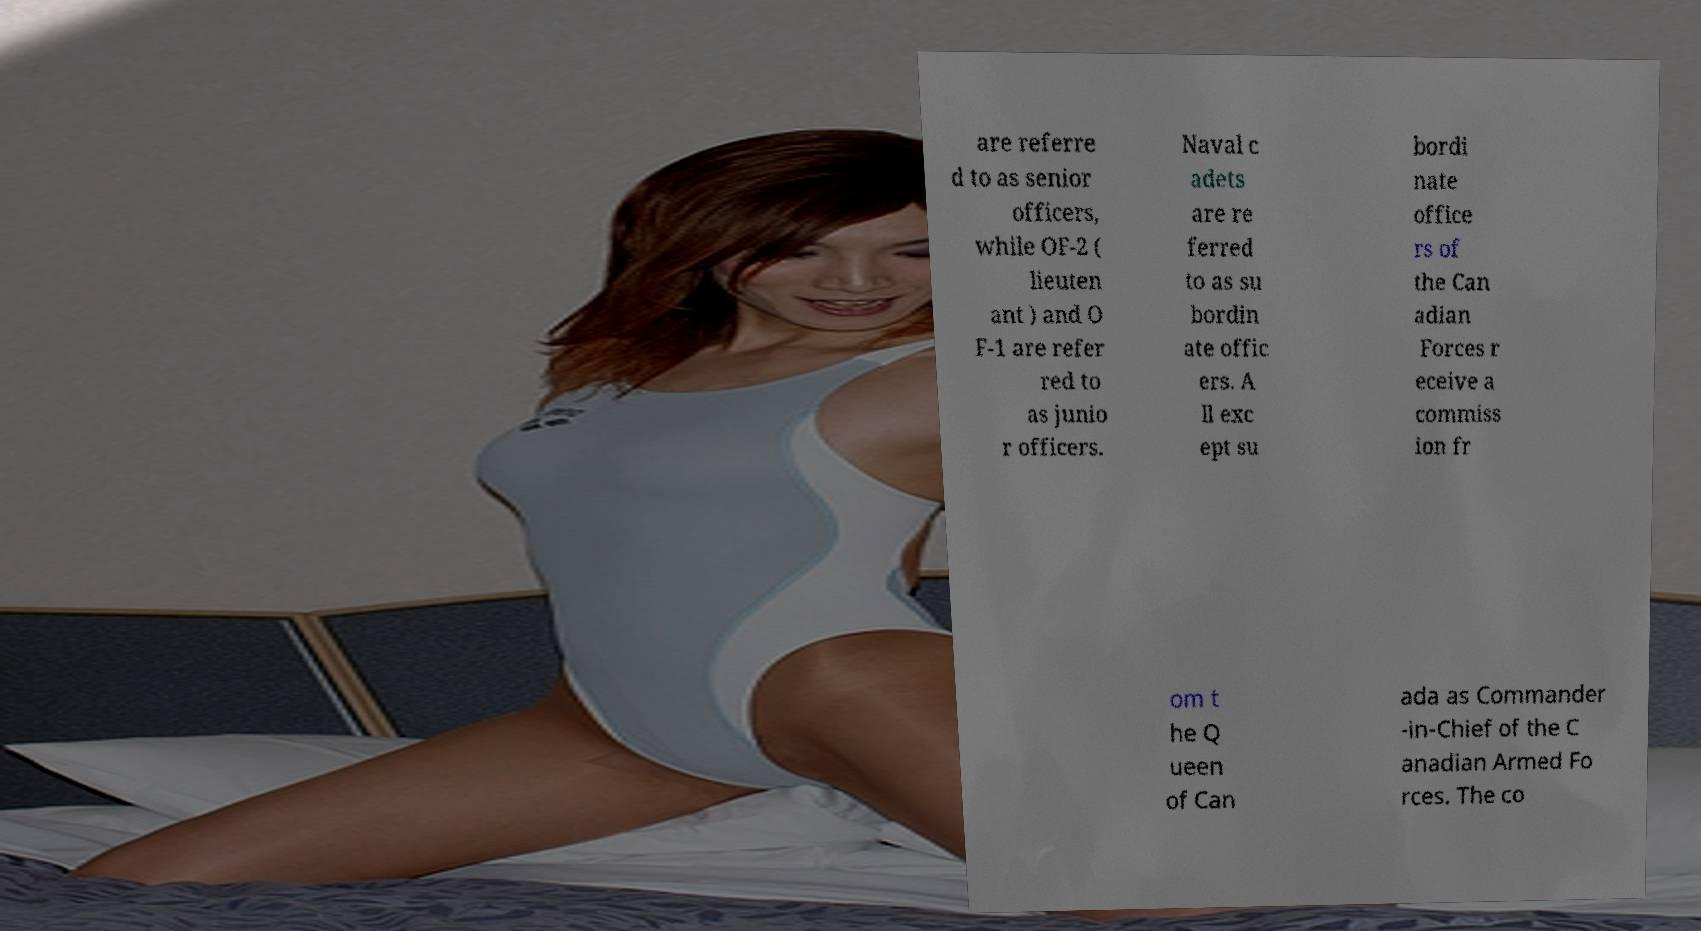There's text embedded in this image that I need extracted. Can you transcribe it verbatim? are referre d to as senior officers, while OF-2 ( lieuten ant ) and O F-1 are refer red to as junio r officers. Naval c adets are re ferred to as su bordin ate offic ers. A ll exc ept su bordi nate office rs of the Can adian Forces r eceive a commiss ion fr om t he Q ueen of Can ada as Commander -in-Chief of the C anadian Armed Fo rces. The co 